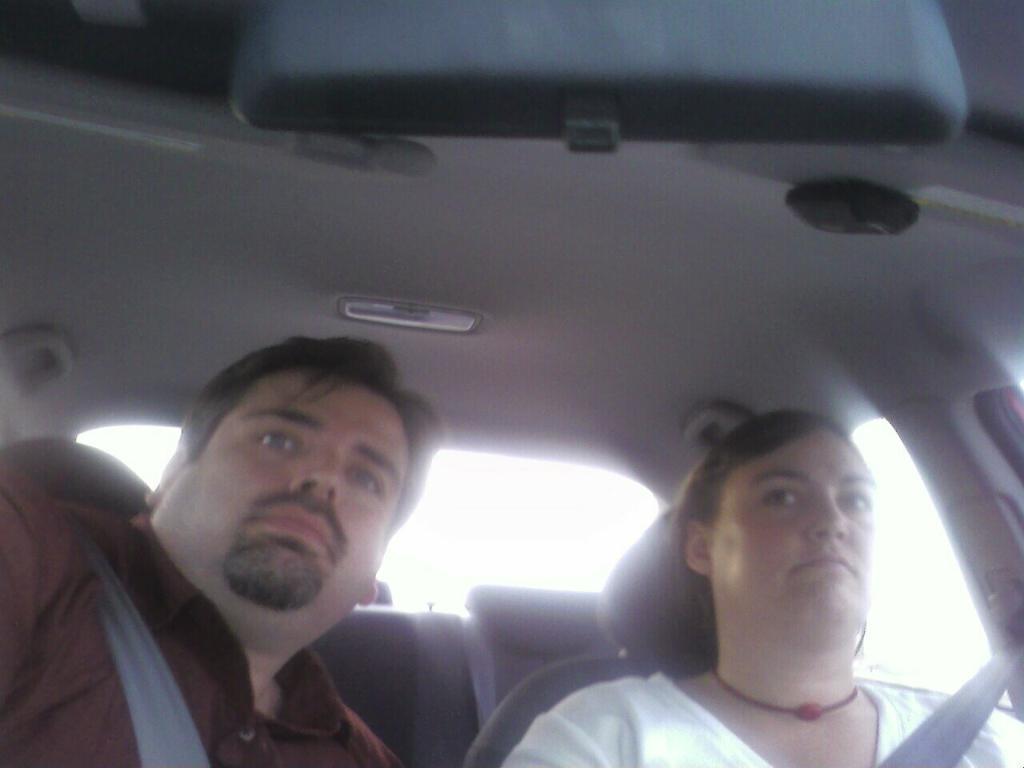How would you summarize this image in a sentence or two? In this image, we can see people in the vehicle and are wearing seat belts. At the top, there is a mirror and a light. 